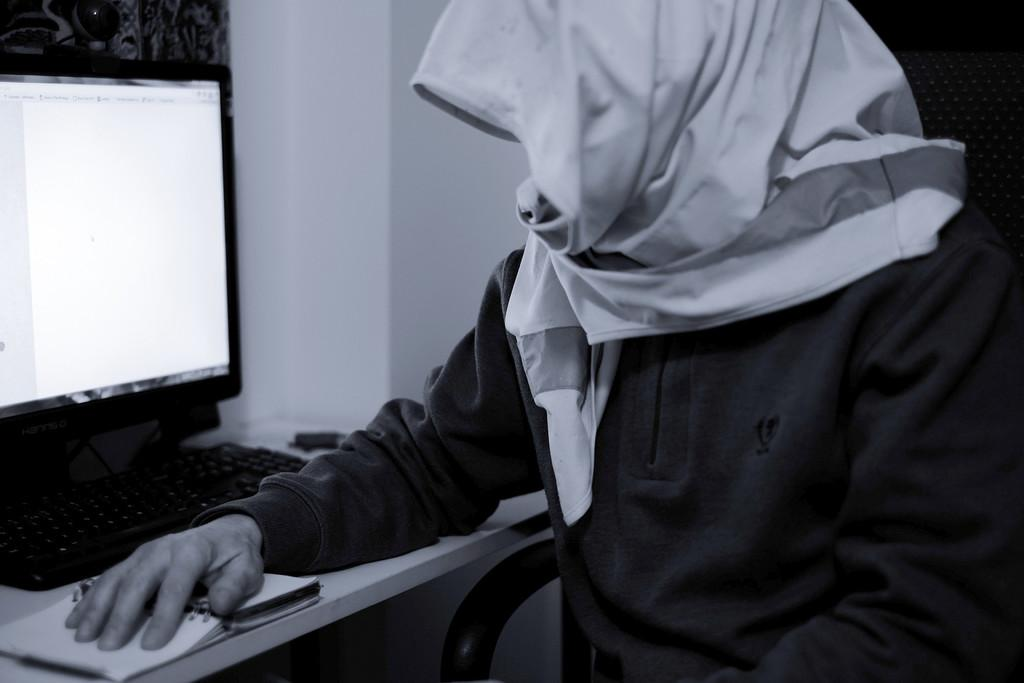What is the person in the image doing? The person is sitting on a chair in the image. What is the person wearing on their head? The person has a scarf on their head. What piece of furniture is in the image? There is a table in the image. What electronic device is on the table? A computer is present on the table. What object is under the person's hand? There is a book under the person's hand. What color is the balloon floating above the person's head in the image? There is no balloon present in the image; the person has a scarf on their head. What type of pot is used to cook the meal in the image? There is no pot or meal present in the image; the person is sitting with a computer and a book. 